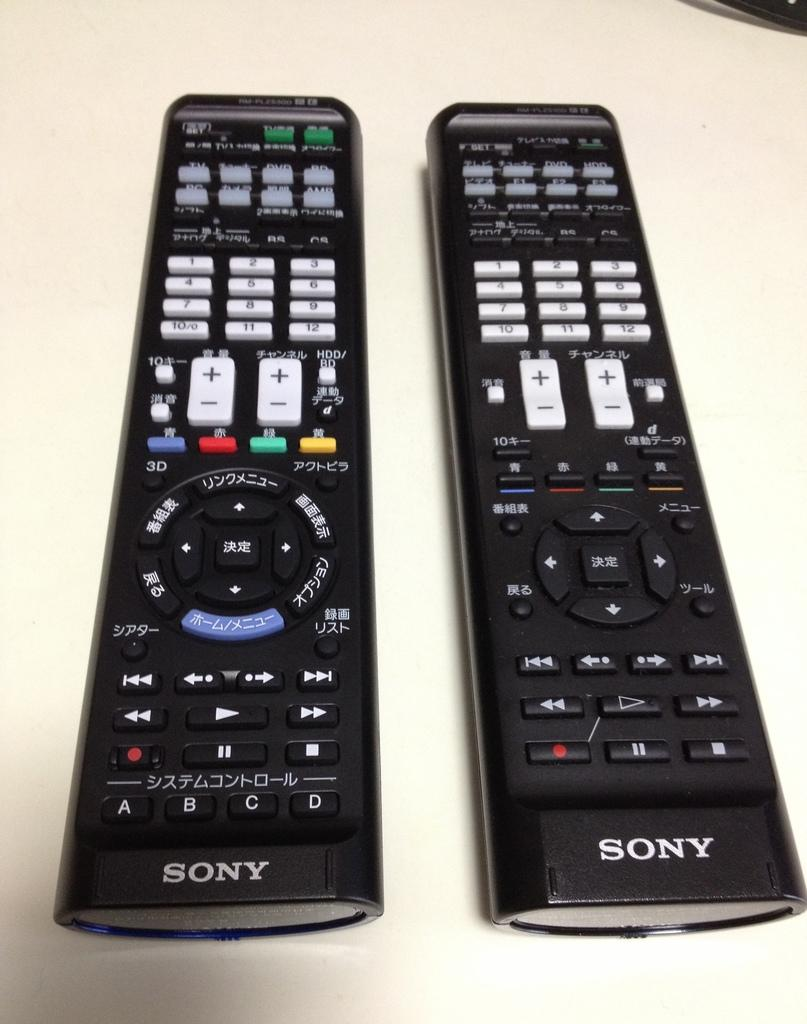<image>
Write a terse but informative summary of the picture. Two Sony remote controls, one with Asian writing, sit side by side. 